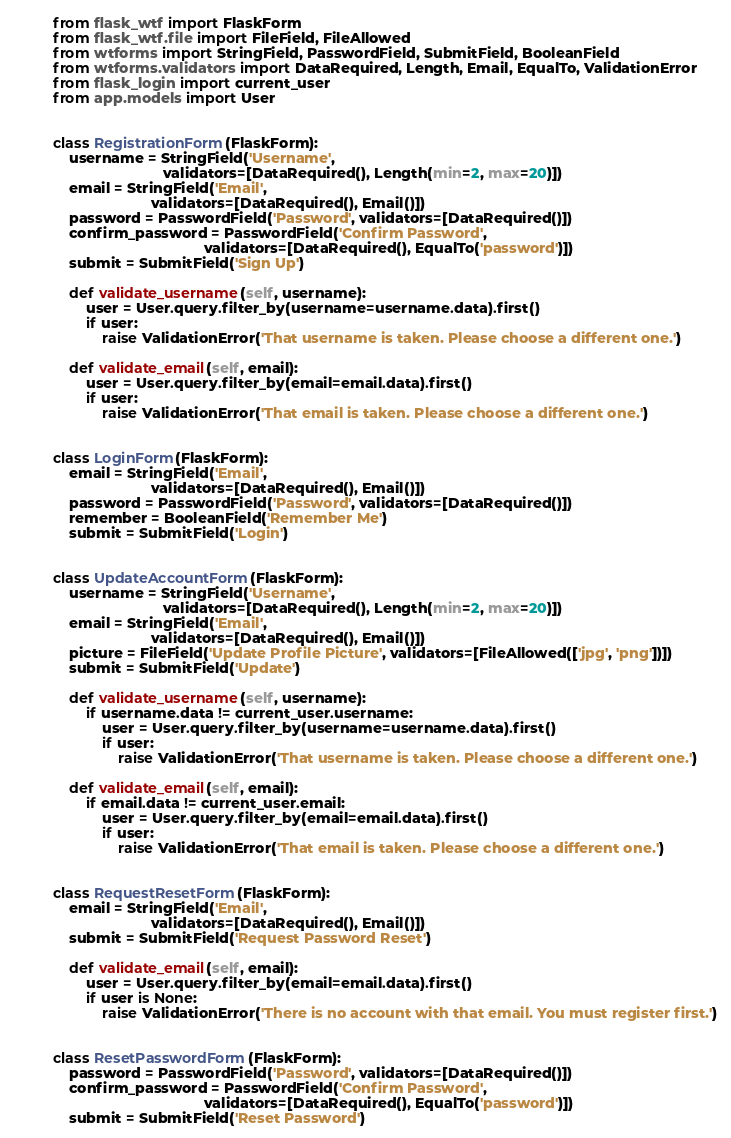<code> <loc_0><loc_0><loc_500><loc_500><_Python_>from flask_wtf import FlaskForm
from flask_wtf.file import FileField, FileAllowed
from wtforms import StringField, PasswordField, SubmitField, BooleanField
from wtforms.validators import DataRequired, Length, Email, EqualTo, ValidationError
from flask_login import current_user
from app.models import User

 
class RegistrationForm(FlaskForm):
    username = StringField('Username',
                           validators=[DataRequired(), Length(min=2, max=20)])
    email = StringField('Email',
                        validators=[DataRequired(), Email()])
    password = PasswordField('Password', validators=[DataRequired()])
    confirm_password = PasswordField('Confirm Password',
                                     validators=[DataRequired(), EqualTo('password')])
    submit = SubmitField('Sign Up')

    def validate_username(self, username):
        user = User.query.filter_by(username=username.data).first()
        if user:
            raise ValidationError('That username is taken. Please choose a different one.')

    def validate_email(self, email):
        user = User.query.filter_by(email=email.data).first()
        if user:
            raise ValidationError('That email is taken. Please choose a different one.')


class LoginForm(FlaskForm):
    email = StringField('Email',
                        validators=[DataRequired(), Email()])
    password = PasswordField('Password', validators=[DataRequired()])
    remember = BooleanField('Remember Me')
    submit = SubmitField('Login')


class UpdateAccountForm(FlaskForm):
    username = StringField('Username',
                           validators=[DataRequired(), Length(min=2, max=20)])
    email = StringField('Email',
                        validators=[DataRequired(), Email()])
    picture = FileField('Update Profile Picture', validators=[FileAllowed(['jpg', 'png'])])
    submit = SubmitField('Update')

    def validate_username(self, username):
        if username.data != current_user.username:
            user = User.query.filter_by(username=username.data).first()
            if user:
                raise ValidationError('That username is taken. Please choose a different one.')

    def validate_email(self, email):
        if email.data != current_user.email:
            user = User.query.filter_by(email=email.data).first()
            if user:
                raise ValidationError('That email is taken. Please choose a different one.')


class RequestResetForm(FlaskForm):
    email = StringField('Email',
                        validators=[DataRequired(), Email()])
    submit = SubmitField('Request Password Reset')

    def validate_email(self, email):
        user = User.query.filter_by(email=email.data).first()
        if user is None:
            raise ValidationError('There is no account with that email. You must register first.')


class ResetPasswordForm(FlaskForm):
    password = PasswordField('Password', validators=[DataRequired()])
    confirm_password = PasswordField('Confirm Password',
                                     validators=[DataRequired(), EqualTo('password')])
    submit = SubmitField('Reset Password')</code> 